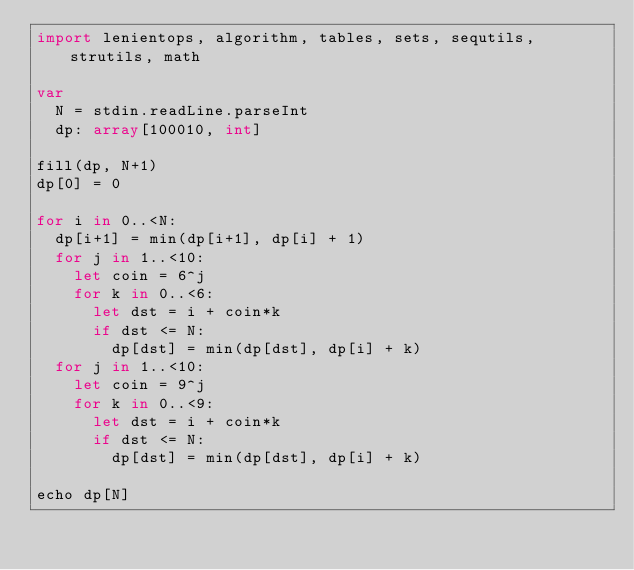Convert code to text. <code><loc_0><loc_0><loc_500><loc_500><_Nim_>import lenientops, algorithm, tables, sets, sequtils, strutils, math

var
  N = stdin.readLine.parseInt
  dp: array[100010, int]

fill(dp, N+1)
dp[0] = 0

for i in 0..<N:
  dp[i+1] = min(dp[i+1], dp[i] + 1)
  for j in 1..<10:
    let coin = 6^j
    for k in 0..<6:
      let dst = i + coin*k
      if dst <= N:
        dp[dst] = min(dp[dst], dp[i] + k)
  for j in 1..<10:
    let coin = 9^j
    for k in 0..<9:
      let dst = i + coin*k
      if dst <= N:
        dp[dst] = min(dp[dst], dp[i] + k)
        
echo dp[N]</code> 